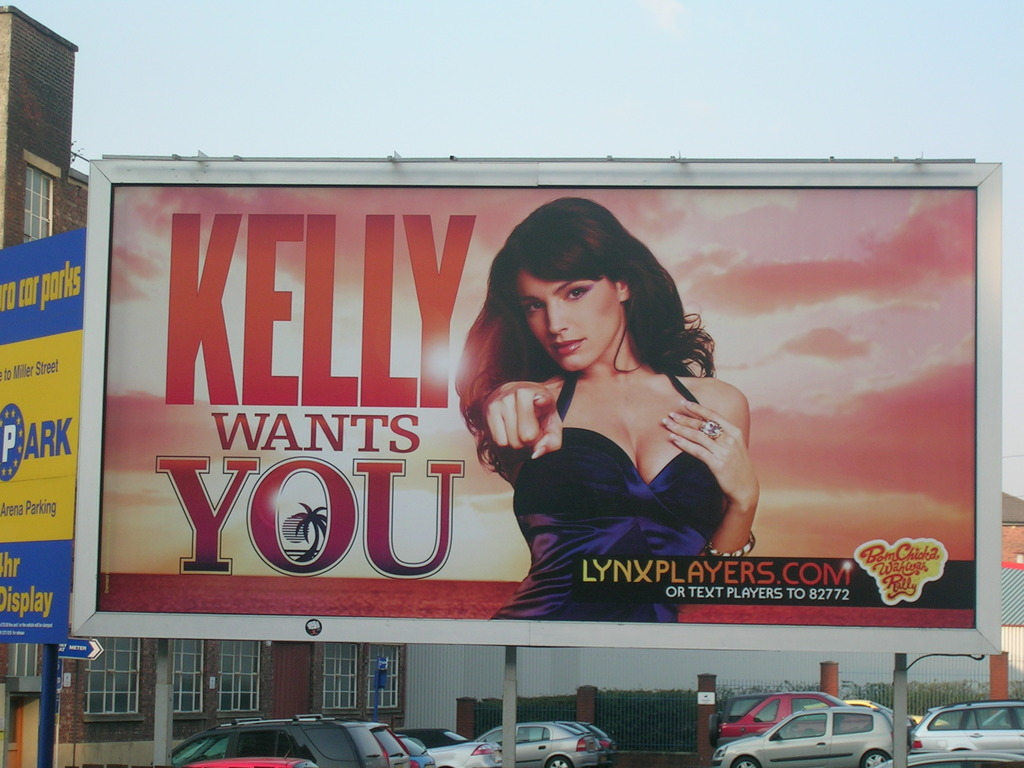Can you describe any visual elements that enhance the effectiveness of this advertisement? The advertisement effectively uses bold text and a direct gaze from the woman to create a personal connection with viewers. The warm colors and sunset background add a dreamy, aspirational quality, while the clear prominence of the website encourages immediate online engagement. 